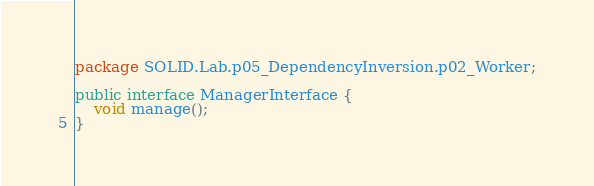Convert code to text. <code><loc_0><loc_0><loc_500><loc_500><_Java_>package SOLID.Lab.p05_DependencyInversion.p02_Worker;

public interface ManagerInterface {
    void manage();
}
</code> 